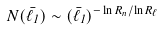Convert formula to latex. <formula><loc_0><loc_0><loc_500><loc_500>N ( \bar { \ell } _ { 1 } ) \sim ( \bar { \ell } _ { 1 } ) ^ { - \ln R _ { n } / \ln R _ { \ell } }</formula> 